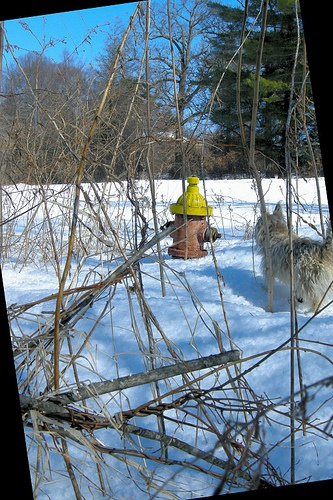Describe the objects in this image and their specific colors. I can see dog in black, gray, and darkgray tones and fire hydrant in black, gray, and olive tones in this image. 